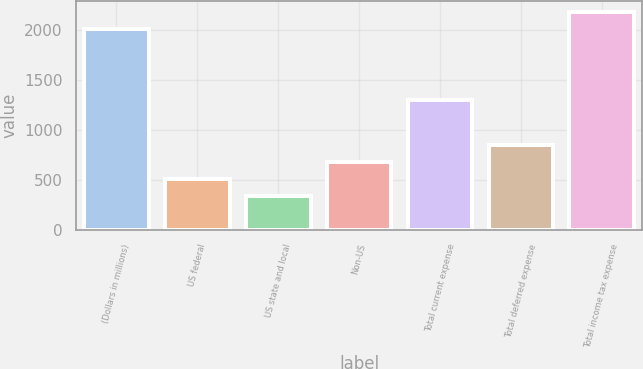Convert chart to OTSL. <chart><loc_0><loc_0><loc_500><loc_500><bar_chart><fcel>(Dollars in millions)<fcel>US federal<fcel>US state and local<fcel>Non-US<fcel>Total current expense<fcel>Total deferred expense<fcel>Total income tax expense<nl><fcel>2014<fcel>508.2<fcel>340<fcel>676.4<fcel>1296<fcel>844.6<fcel>2182.2<nl></chart> 